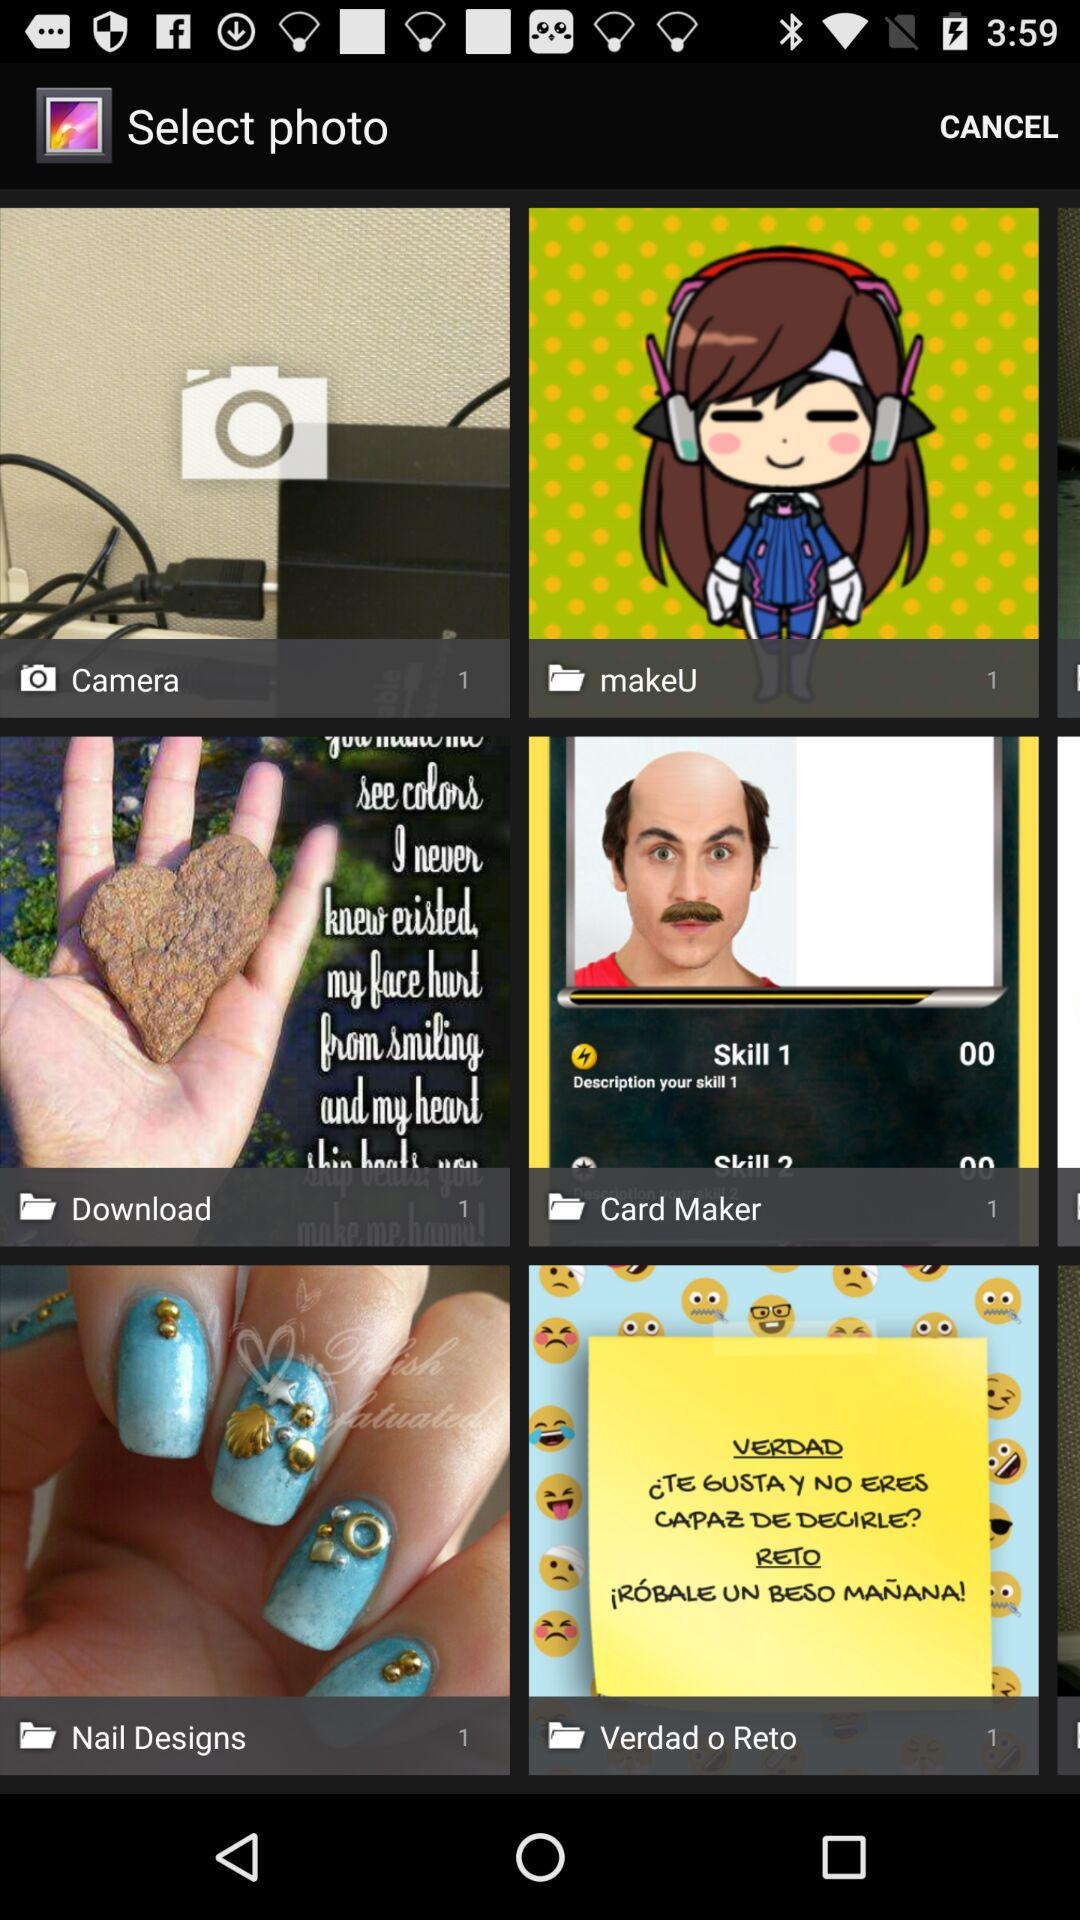How many photos are there in "Camera"? There is 1 photo in "Camera". 